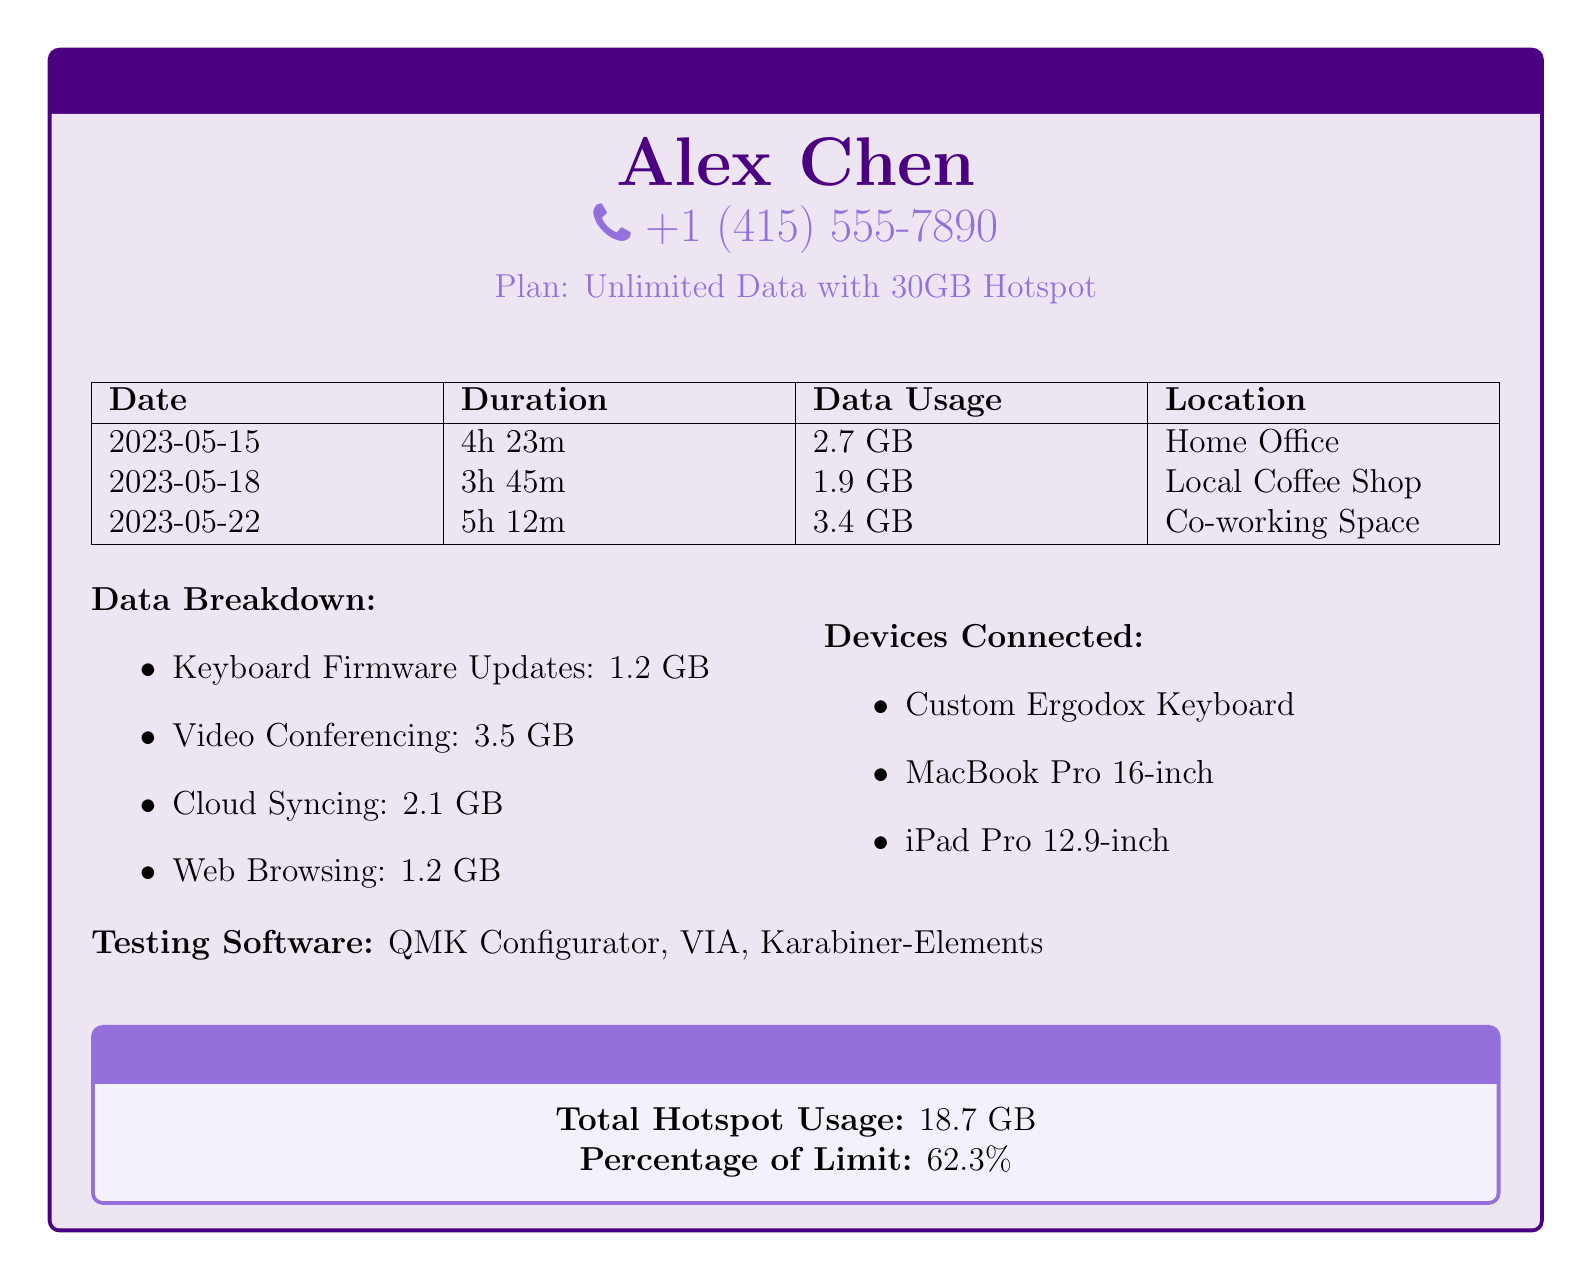What is the name of the user? The document identifies the user as Alex Chen.
Answer: Alex Chen What is the phone number listed? The document provides the phone number as +1 (415) 555-7890.
Answer: +1 (415) 555-7890 What is the total data usage during remote sessions? The total data usage of 18.7 GB is indicated in the monthly usage summary.
Answer: 18.7 GB How many devices were connected? The document lists three devices connected during the sessions.
Answer: 3 devices What is the duration of the longest session? The longest session mentioned is 5 hours and 12 minutes on 2023-05-22.
Answer: 5h 12m What percentage of the data limit has been used? The document states that 62.3% of the data limit has been used.
Answer: 62.3% How much data was used for keyboard firmware updates? The report indicates that 1.2 GB was used for keyboard firmware updates.
Answer: 1.2 GB What location was used for the session on May 18? The document specifies that the session on May 18 occurred at a local coffee shop.
Answer: Local Coffee Shop Which software was tested according to the document? The document lists QMK Configurator, VIA, and Karabiner-Elements as the testing software.
Answer: QMK Configurator, VIA, Karabiner-Elements 